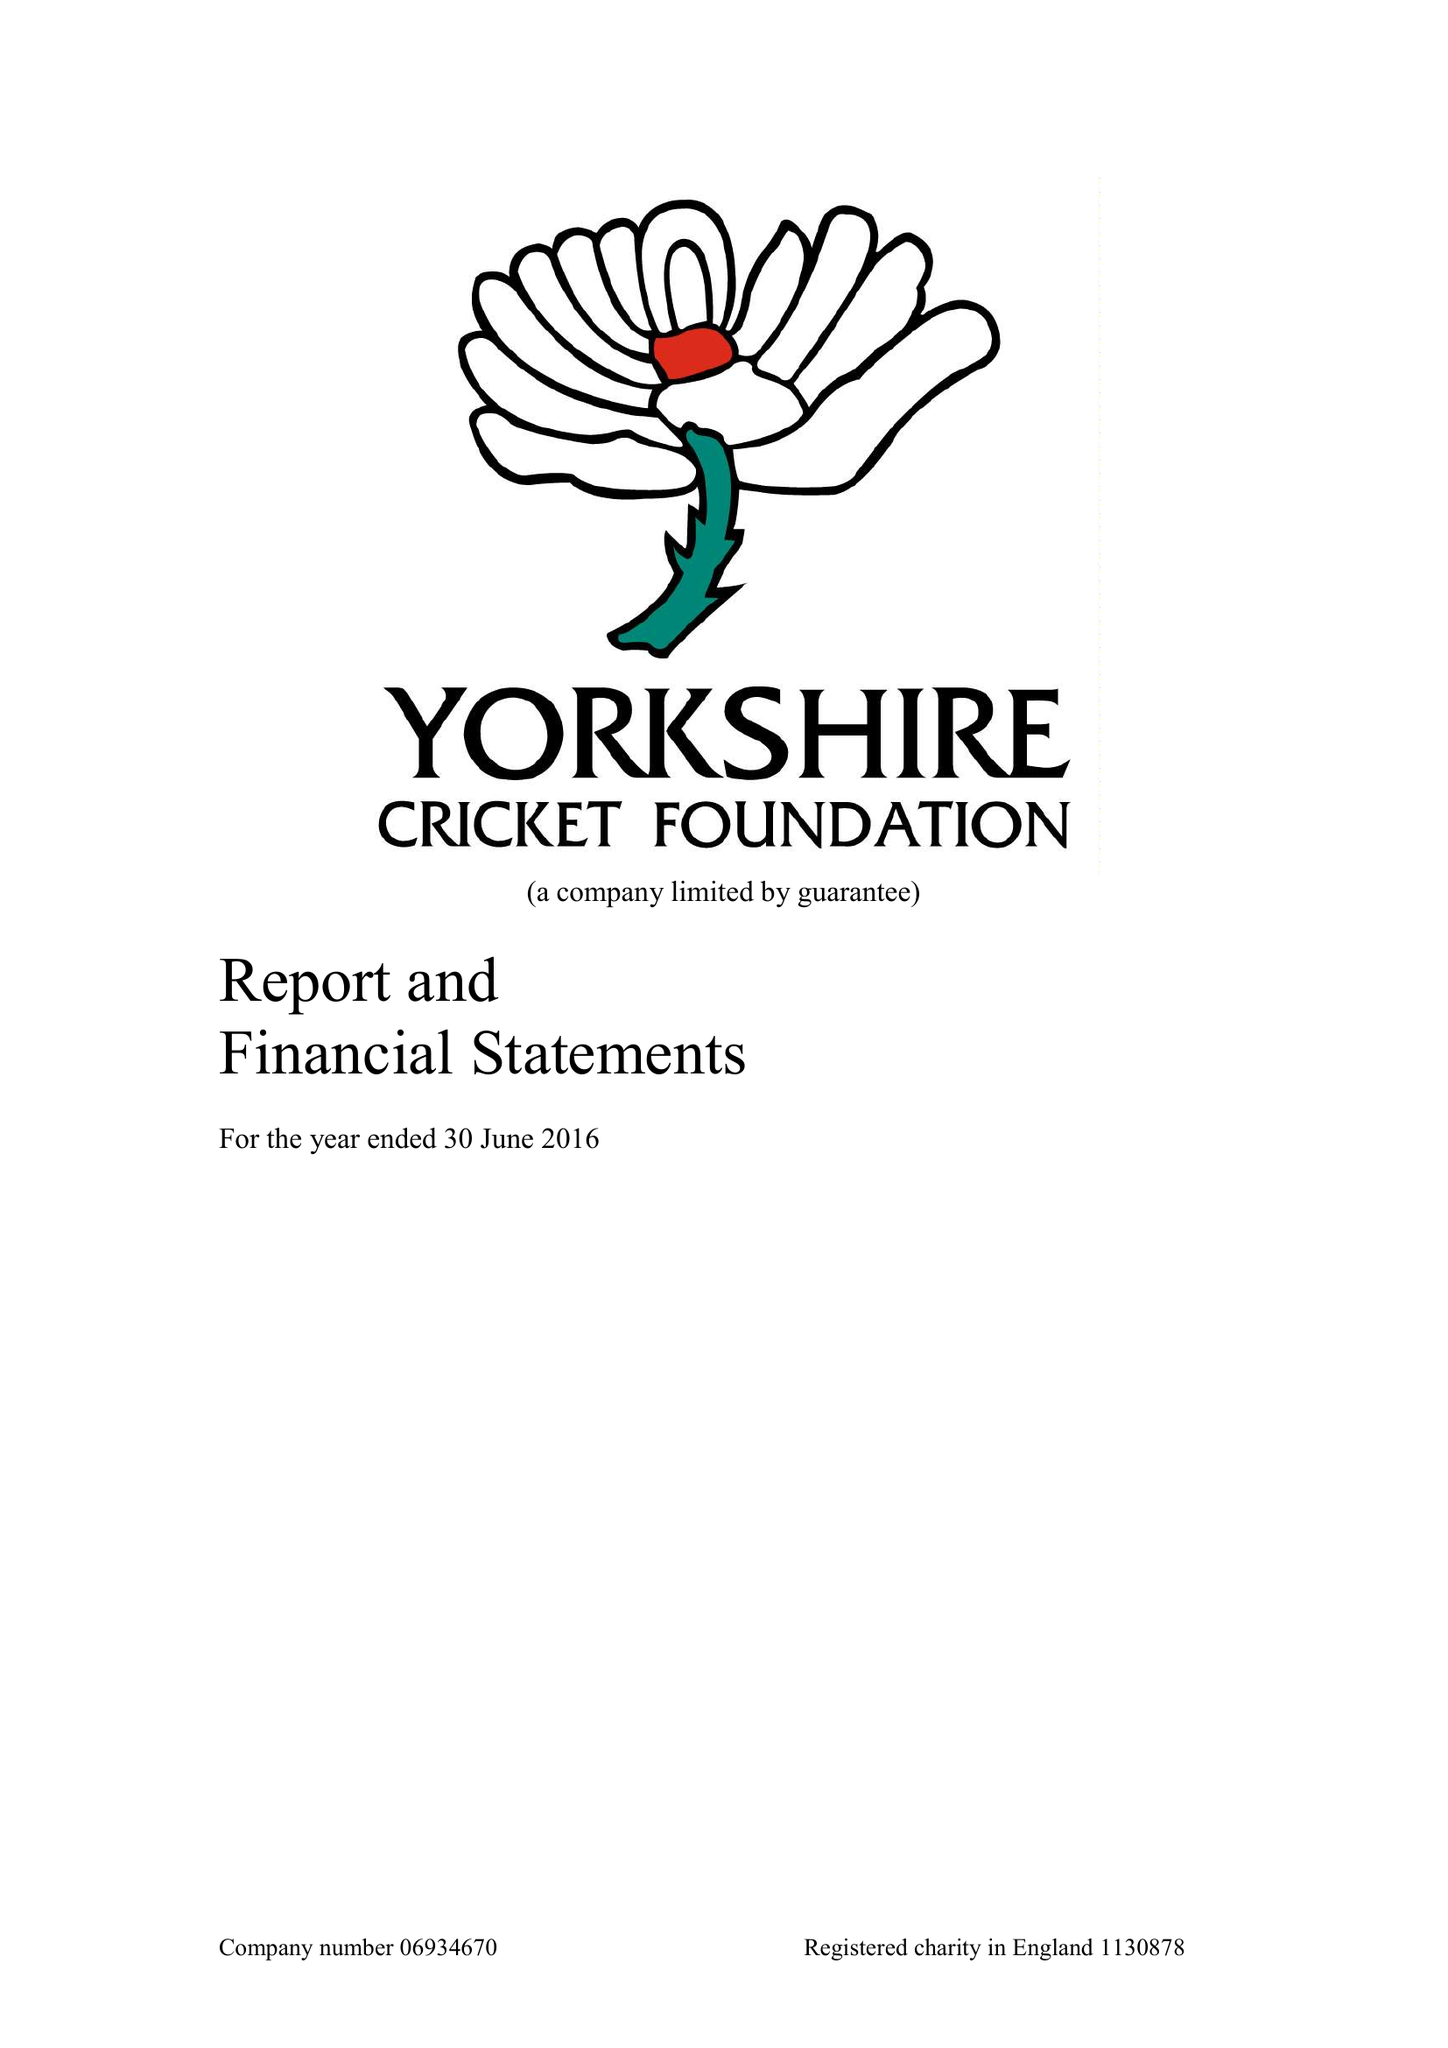What is the value for the report_date?
Answer the question using a single word or phrase. 2016-06-30 